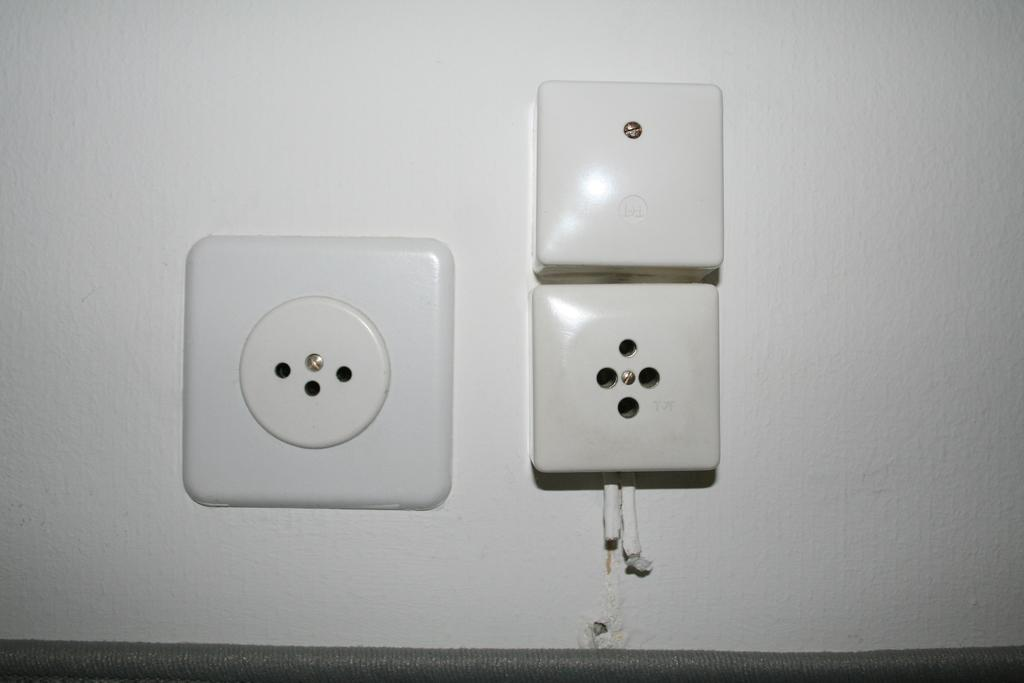What can be seen on the wall in the image? There are sockets on a white wall in the image. What color is the wall where the sockets are located? The wall is white. How many shoes are placed on the sockets in the image? There are no shoes present in the image; it only shows sockets on a white wall. What type of dirt can be seen on the sockets in the image? There is no dirt visible on the sockets in the image, as they are on a white wall. 